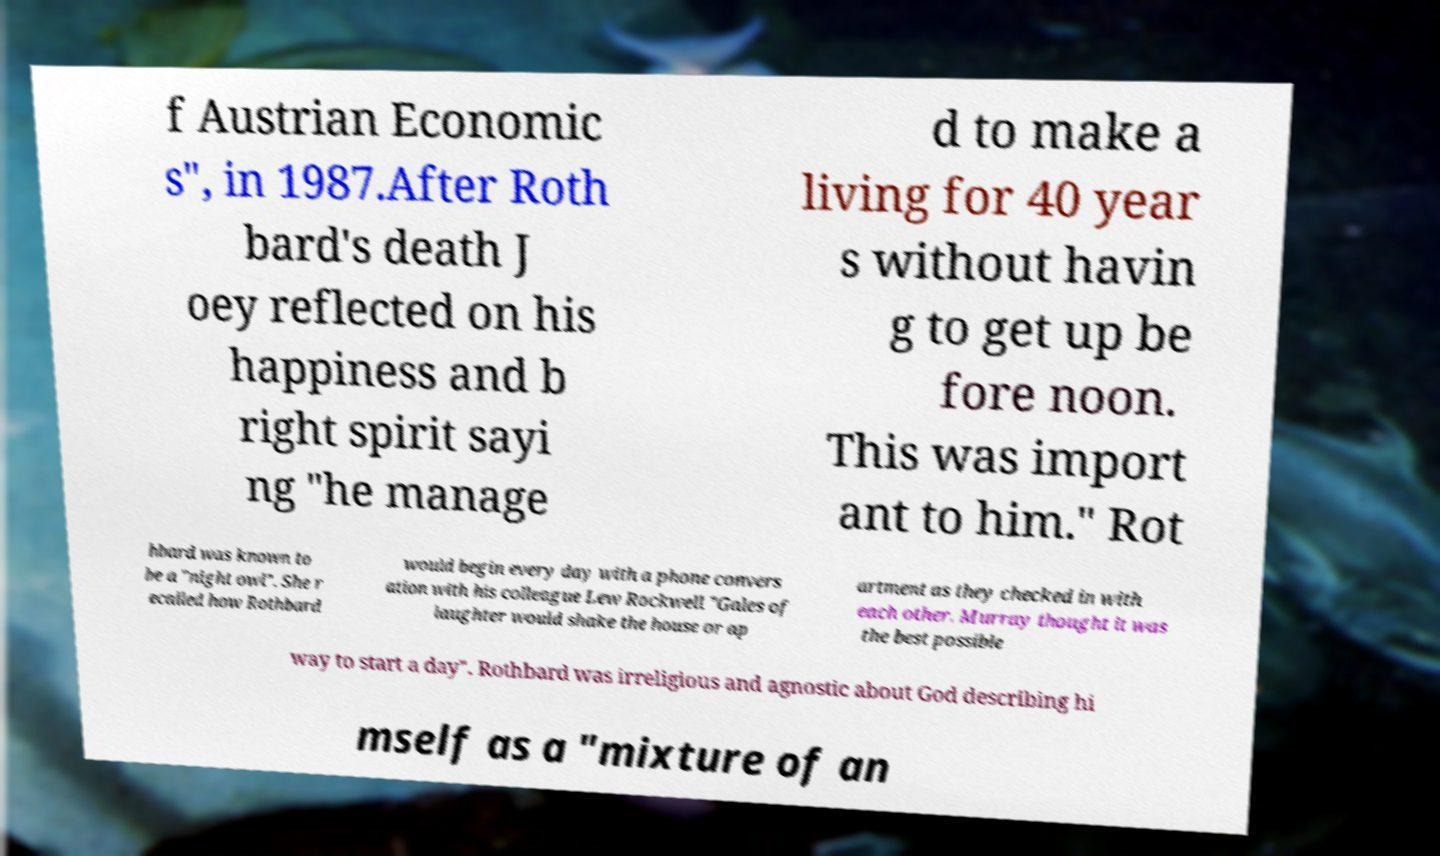There's text embedded in this image that I need extracted. Can you transcribe it verbatim? f Austrian Economic s", in 1987.After Roth bard's death J oey reflected on his happiness and b right spirit sayi ng "he manage d to make a living for 40 year s without havin g to get up be fore noon. This was import ant to him." Rot hbard was known to be a "night owl". She r ecalled how Rothbard would begin every day with a phone convers ation with his colleague Lew Rockwell "Gales of laughter would shake the house or ap artment as they checked in with each other. Murray thought it was the best possible way to start a day". Rothbard was irreligious and agnostic about God describing hi mself as a "mixture of an 